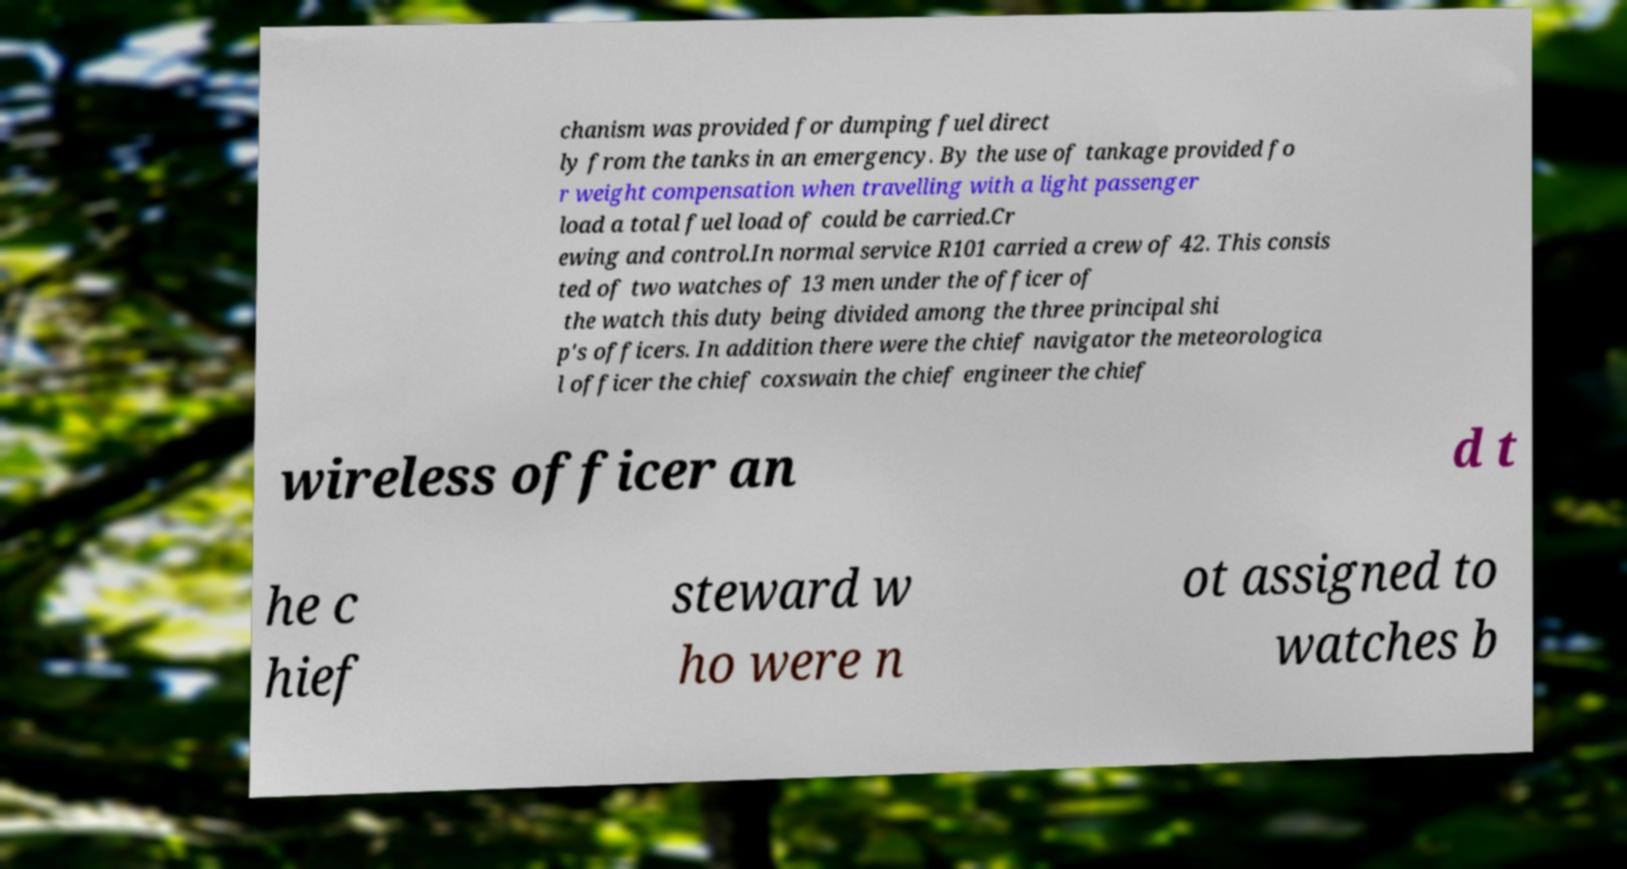I need the written content from this picture converted into text. Can you do that? chanism was provided for dumping fuel direct ly from the tanks in an emergency. By the use of tankage provided fo r weight compensation when travelling with a light passenger load a total fuel load of could be carried.Cr ewing and control.In normal service R101 carried a crew of 42. This consis ted of two watches of 13 men under the officer of the watch this duty being divided among the three principal shi p's officers. In addition there were the chief navigator the meteorologica l officer the chief coxswain the chief engineer the chief wireless officer an d t he c hief steward w ho were n ot assigned to watches b 